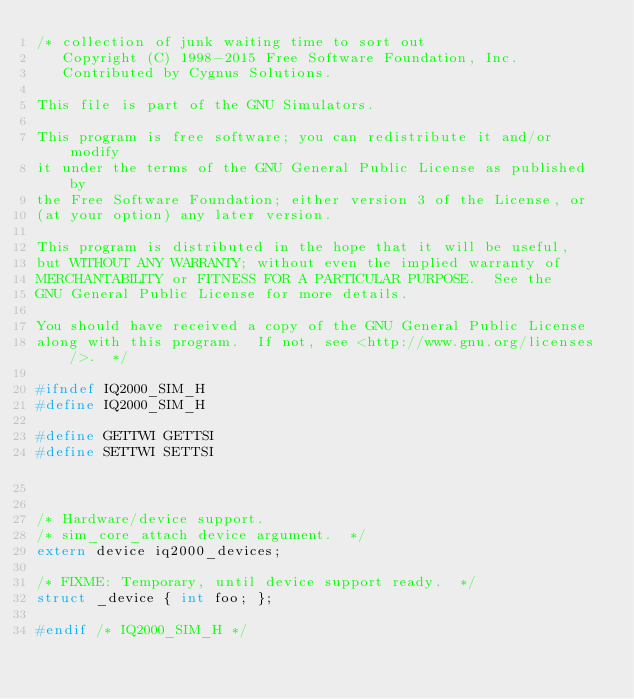<code> <loc_0><loc_0><loc_500><loc_500><_C_>/* collection of junk waiting time to sort out
   Copyright (C) 1998-2015 Free Software Foundation, Inc.
   Contributed by Cygnus Solutions.

This file is part of the GNU Simulators.

This program is free software; you can redistribute it and/or modify
it under the terms of the GNU General Public License as published by
the Free Software Foundation; either version 3 of the License, or
(at your option) any later version.

This program is distributed in the hope that it will be useful,
but WITHOUT ANY WARRANTY; without even the implied warranty of
MERCHANTABILITY or FITNESS FOR A PARTICULAR PURPOSE.  See the
GNU General Public License for more details.

You should have received a copy of the GNU General Public License
along with this program.  If not, see <http://www.gnu.org/licenses/>.  */

#ifndef IQ2000_SIM_H
#define IQ2000_SIM_H

#define GETTWI GETTSI
#define SETTWI SETTSI


/* Hardware/device support.
/* sim_core_attach device argument.  */
extern device iq2000_devices;

/* FIXME: Temporary, until device support ready.  */
struct _device { int foo; };

#endif /* IQ2000_SIM_H */
</code> 